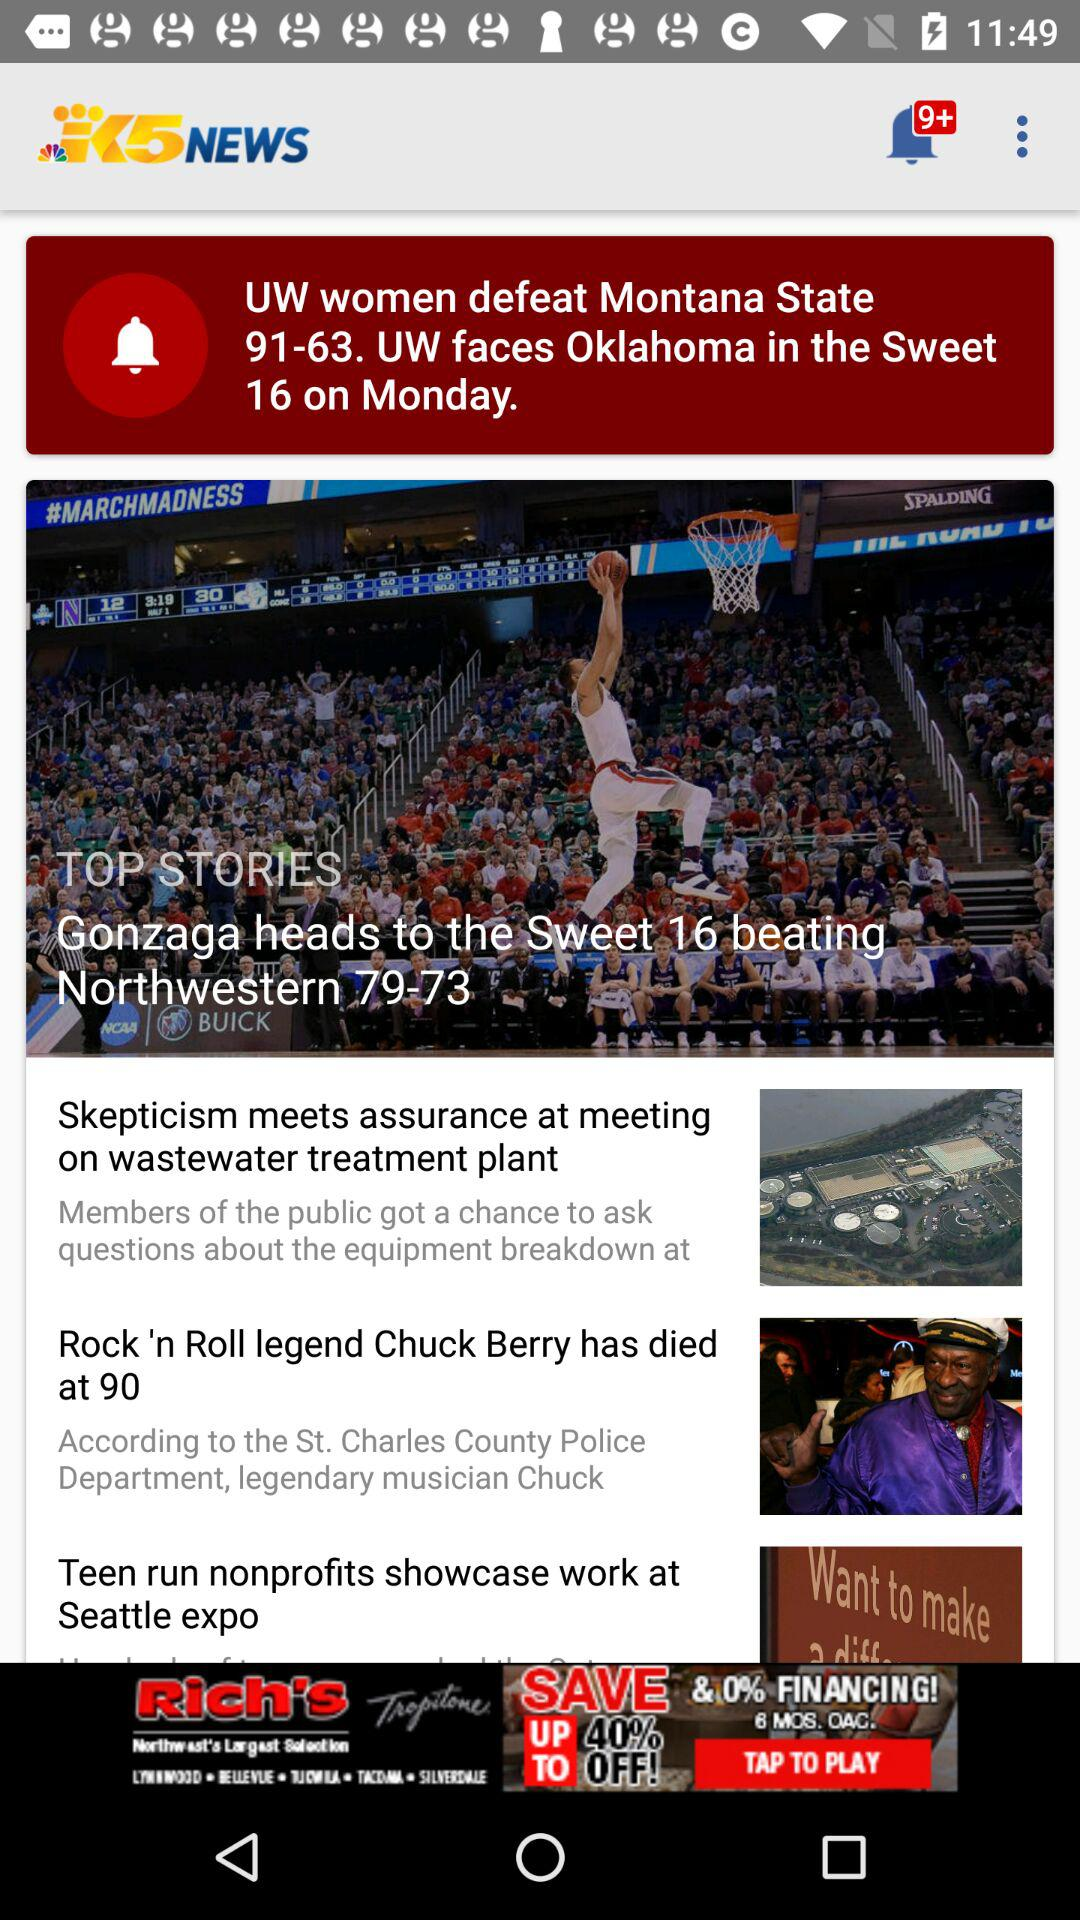How many unread notifications are in this? There are 9+ unread notifications. 